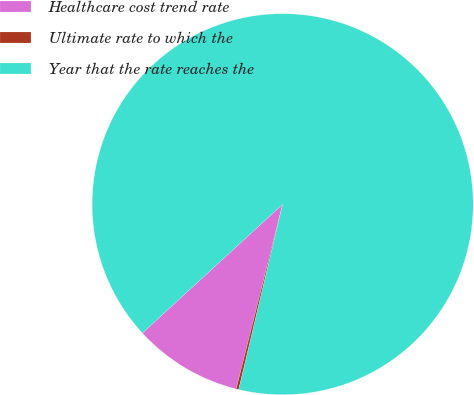<chart> <loc_0><loc_0><loc_500><loc_500><pie_chart><fcel>Healthcare cost trend rate<fcel>Ultimate rate to which the<fcel>Year that the rate reaches the<nl><fcel>9.25%<fcel>0.22%<fcel>90.52%<nl></chart> 